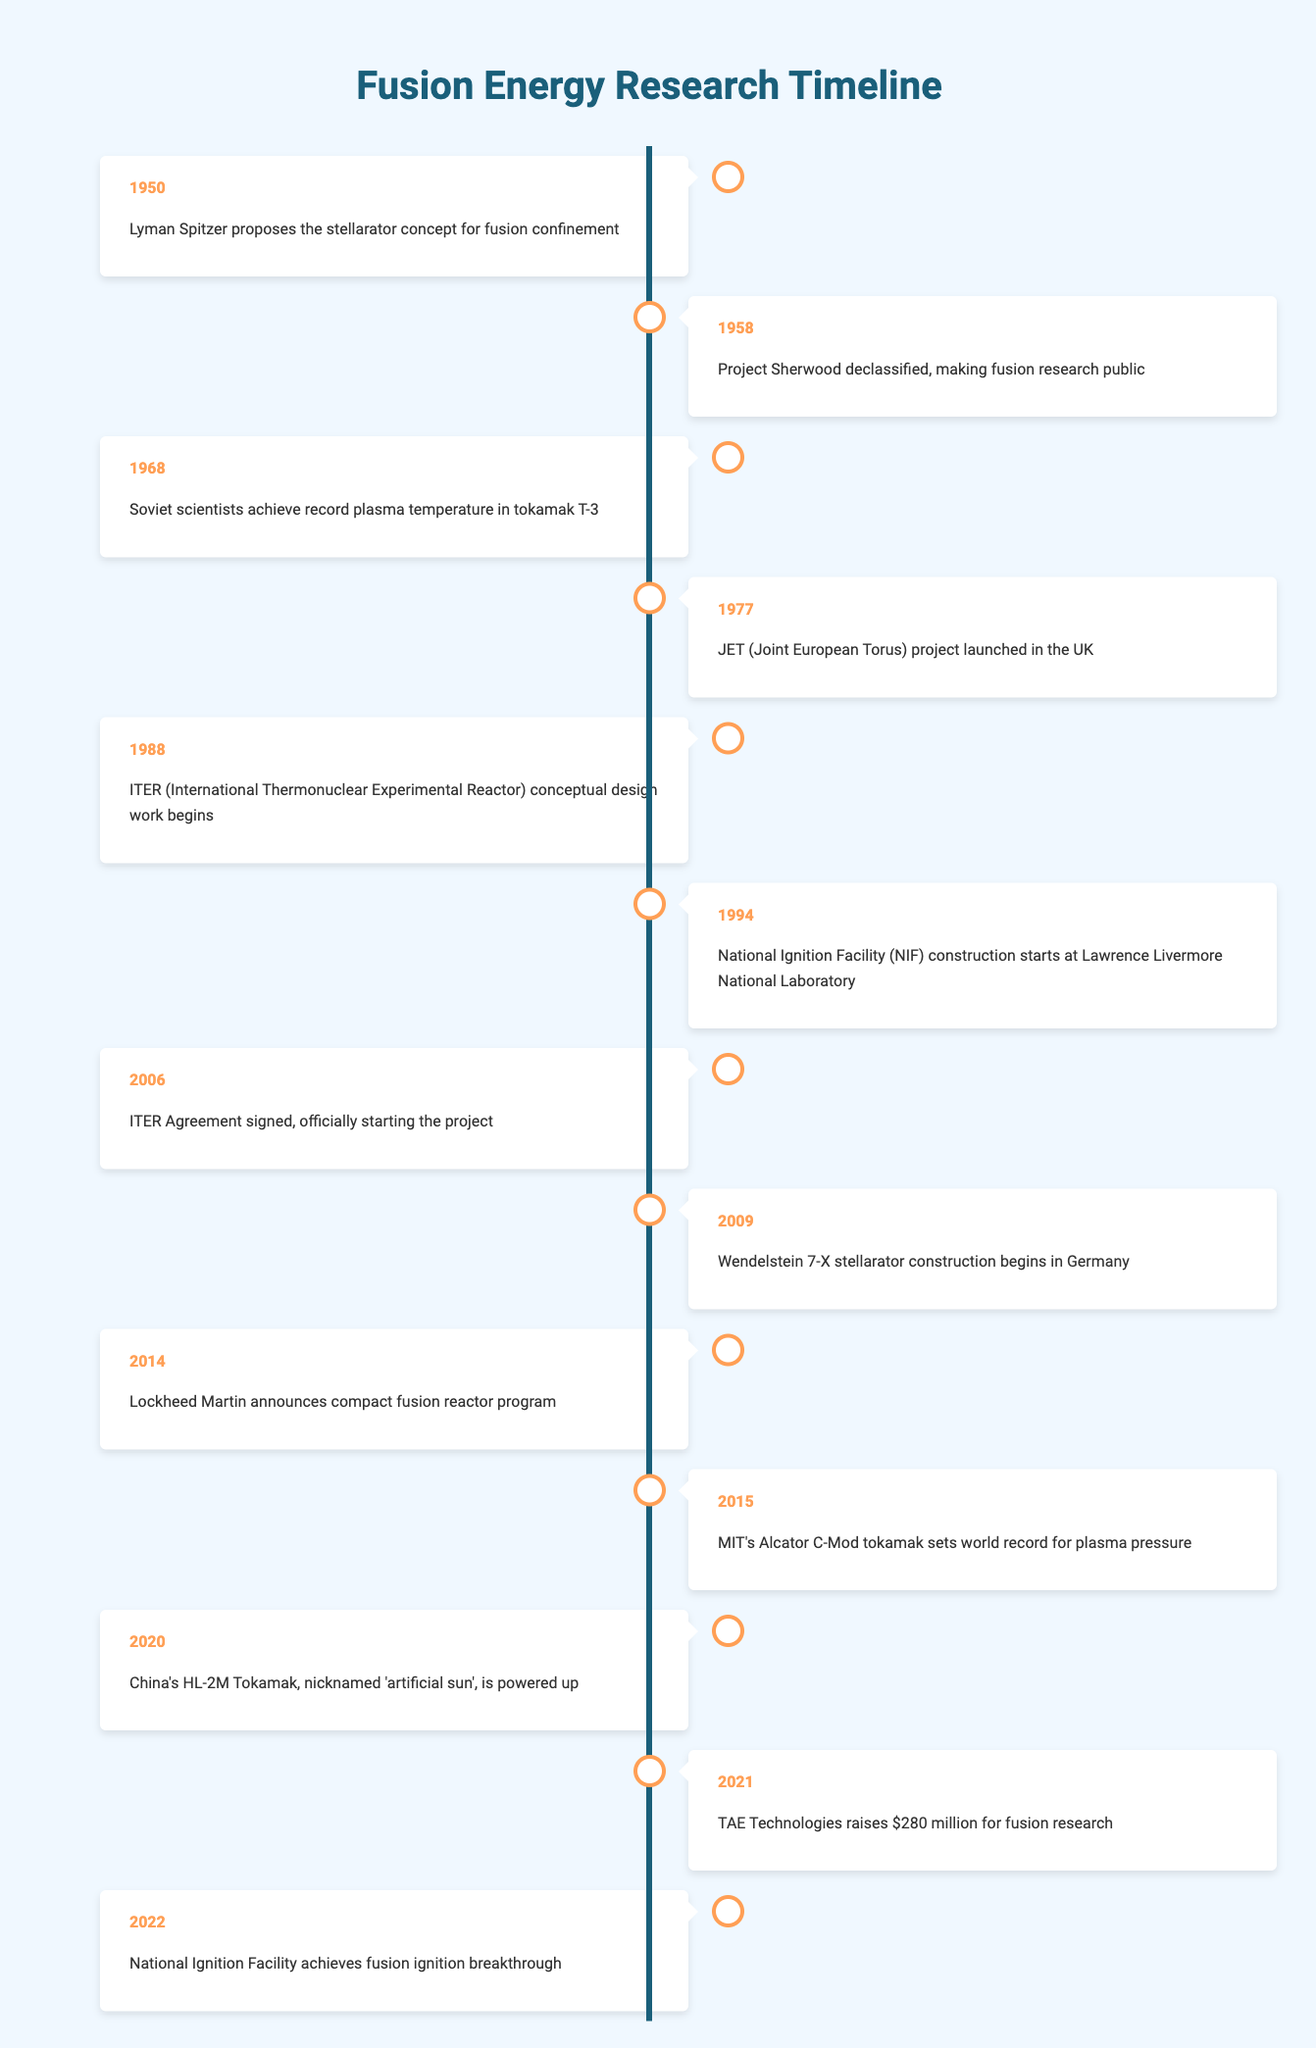What year did the National Ignition Facility achieve fusion ignition breakthrough? The table indicates that the National Ignition Facility achieved fusion ignition breakthrough in the year 2022.
Answer: 2022 Which project started in 2006? Referring to the timeline, the specific project that officially began in 2006 is the ITER Agreement signing.
Answer: ITER Agreement What is the earliest event listed in this timeline? The earliest event in the timeline is Lyman Spitzer proposing the stellarator concept, which took place in 1950.
Answer: 1950 In what year was the Joint European Torus project launched? The table states that the JET project was launched in the year 1977, according to the event listed for that year.
Answer: 1977 How many years were there between the signing of the ITER Agreement and the first achievement of fusion ignition? The ITER Agreement was signed in 2006 and the first achievement of fusion ignition occurred in 2022. This means there are 2022 - 2006 = 16 years between these two events.
Answer: 16 Is it true that the International Thermonuclear Experimental Reactor's conceptual design began before the construction of the National Ignition Facility? According to the table, the conceptual design of ITER started in 1988 and the construction of the National Ignition Facility began in 1994. Thus, it is true that ITER started before NIF construction.
Answer: Yes Which event occurred in 2021 related to funding for fusion research? The timeline shows that TAE Technologies raised $280 million for fusion research in the year 2021, answering the question directly.
Answer: TAE Technologies raises $280 million What can be inferred about the trend in fusion energy research based on the number of events after 2000 compared to the previous decades? From the timeline, there are several significant events listed after 2000 (specifically in the years 2006, 2009, 2014, 2015, 2020, 2021, and 2022), indicating an increasing trend in research activities compared to the fewer events prior to the year 2000.
Answer: Increasing trend Which event represents a significant milestone in China’s efforts in fusion technology? The event where China’s HL-2M Tokamak was powered up in 2020 is a significant milestone in their fusion technology efforts, as outlined in the timeline.
Answer: China's HL-2M Tokamak powered up 